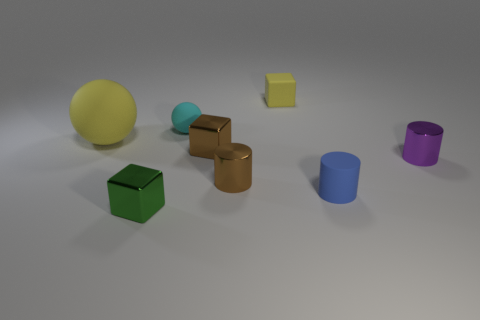Add 2 tiny purple shiny objects. How many objects exist? 10 Subtract all cylinders. How many objects are left? 5 Subtract all tiny brown shiny blocks. Subtract all cyan objects. How many objects are left? 6 Add 3 big yellow matte objects. How many big yellow matte objects are left? 4 Add 3 tiny rubber things. How many tiny rubber things exist? 6 Subtract 0 cyan cubes. How many objects are left? 8 